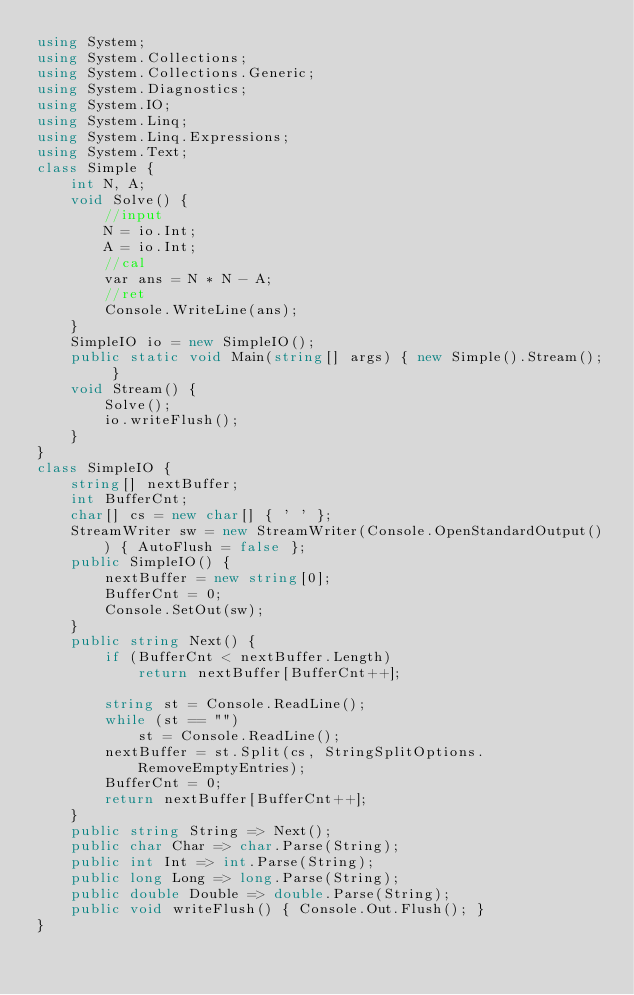<code> <loc_0><loc_0><loc_500><loc_500><_C#_>using System;
using System.Collections;
using System.Collections.Generic;
using System.Diagnostics;
using System.IO;
using System.Linq;
using System.Linq.Expressions;
using System.Text;
class Simple {
    int N, A;
    void Solve() {
        //input
        N = io.Int;
        A = io.Int;
        //cal
        var ans = N * N - A;
        //ret
        Console.WriteLine(ans);
    }    
    SimpleIO io = new SimpleIO();
    public static void Main(string[] args) { new Simple().Stream(); }
    void Stream() {
        Solve();
        io.writeFlush();
    }
}
class SimpleIO {
    string[] nextBuffer;
    int BufferCnt;
    char[] cs = new char[] { ' ' };
    StreamWriter sw = new StreamWriter(Console.OpenStandardOutput()) { AutoFlush = false };
    public SimpleIO() {
        nextBuffer = new string[0];
        BufferCnt = 0;
        Console.SetOut(sw);
    }
    public string Next() {
        if (BufferCnt < nextBuffer.Length)
            return nextBuffer[BufferCnt++];

        string st = Console.ReadLine();
        while (st == "")
            st = Console.ReadLine();
        nextBuffer = st.Split(cs, StringSplitOptions.RemoveEmptyEntries);
        BufferCnt = 0;
        return nextBuffer[BufferCnt++];
    }
    public string String => Next();
    public char Char => char.Parse(String);
    public int Int => int.Parse(String);
    public long Long => long.Parse(String);
    public double Double => double.Parse(String);
    public void writeFlush() { Console.Out.Flush(); }
}
</code> 